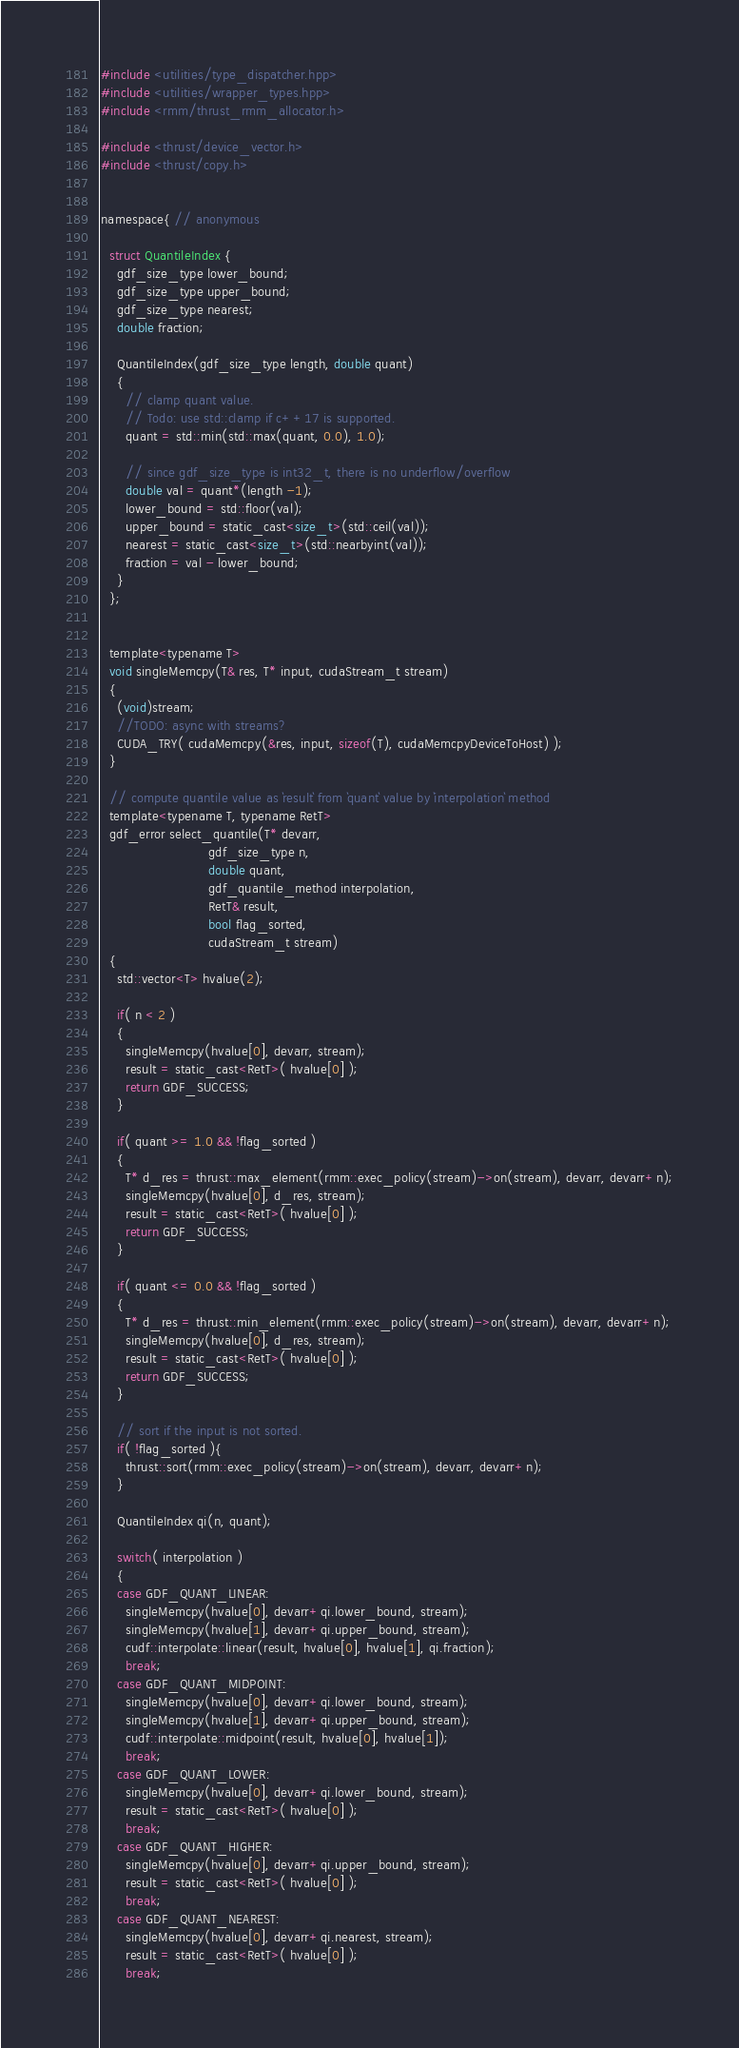<code> <loc_0><loc_0><loc_500><loc_500><_Cuda_>#include <utilities/type_dispatcher.hpp>
#include <utilities/wrapper_types.hpp>
#include <rmm/thrust_rmm_allocator.h>

#include <thrust/device_vector.h>
#include <thrust/copy.h>


namespace{ // anonymous

  struct QuantileIndex {
    gdf_size_type lower_bound;
    gdf_size_type upper_bound;
    gdf_size_type nearest;
    double fraction;

    QuantileIndex(gdf_size_type length, double quant)
    {
      // clamp quant value.
      // Todo: use std::clamp if c++17 is supported.
      quant = std::min(std::max(quant, 0.0), 1.0);

      // since gdf_size_type is int32_t, there is no underflow/overflow
      double val = quant*(length -1);
      lower_bound = std::floor(val);
      upper_bound = static_cast<size_t>(std::ceil(val));
      nearest = static_cast<size_t>(std::nearbyint(val));
      fraction = val - lower_bound;
    }
  };


  template<typename T>
  void singleMemcpy(T& res, T* input, cudaStream_t stream)
  {
    (void)stream;
    //TODO: async with streams?
    CUDA_TRY( cudaMemcpy(&res, input, sizeof(T), cudaMemcpyDeviceToHost) );
  }

  // compute quantile value as `result` from `quant` value by `interpolation` method
  template<typename T, typename RetT>
  gdf_error select_quantile(T* devarr,
                          gdf_size_type n,
                          double quant, 
                          gdf_quantile_method interpolation,
                          RetT& result,
                          bool flag_sorted,
                          cudaStream_t stream)
  {
    std::vector<T> hvalue(2);

    if( n < 2 )
    {
      singleMemcpy(hvalue[0], devarr, stream);
      result = static_cast<RetT>( hvalue[0] );
      return GDF_SUCCESS;
    }

    if( quant >= 1.0 && !flag_sorted )
    {
      T* d_res = thrust::max_element(rmm::exec_policy(stream)->on(stream), devarr, devarr+n);
      singleMemcpy(hvalue[0], d_res, stream);
      result = static_cast<RetT>( hvalue[0] );
      return GDF_SUCCESS;
    }

    if( quant <= 0.0 && !flag_sorted )
    {
      T* d_res = thrust::min_element(rmm::exec_policy(stream)->on(stream), devarr, devarr+n);
      singleMemcpy(hvalue[0], d_res, stream);
      result = static_cast<RetT>( hvalue[0] );
      return GDF_SUCCESS;
    }

    // sort if the input is not sorted.
    if( !flag_sorted ){
      thrust::sort(rmm::exec_policy(stream)->on(stream), devarr, devarr+n);
    }

    QuantileIndex qi(n, quant);

    switch( interpolation )
    {
    case GDF_QUANT_LINEAR:
      singleMemcpy(hvalue[0], devarr+qi.lower_bound, stream);
      singleMemcpy(hvalue[1], devarr+qi.upper_bound, stream);
      cudf::interpolate::linear(result, hvalue[0], hvalue[1], qi.fraction);
      break;
    case GDF_QUANT_MIDPOINT:
      singleMemcpy(hvalue[0], devarr+qi.lower_bound, stream);
      singleMemcpy(hvalue[1], devarr+qi.upper_bound, stream);
      cudf::interpolate::midpoint(result, hvalue[0], hvalue[1]);
      break;
    case GDF_QUANT_LOWER:
      singleMemcpy(hvalue[0], devarr+qi.lower_bound, stream);
      result = static_cast<RetT>( hvalue[0] );
      break;
    case GDF_QUANT_HIGHER:
      singleMemcpy(hvalue[0], devarr+qi.upper_bound, stream);
      result = static_cast<RetT>( hvalue[0] );
      break;
    case GDF_QUANT_NEAREST:
      singleMemcpy(hvalue[0], devarr+qi.nearest, stream);
      result = static_cast<RetT>( hvalue[0] );
      break;
</code> 